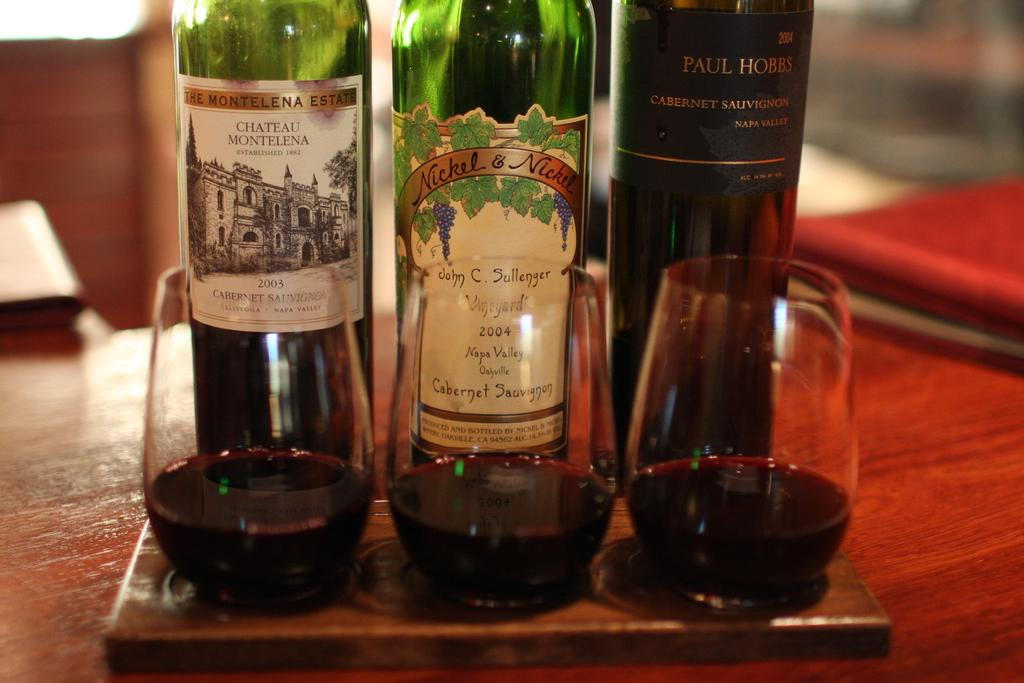<image>
Share a concise interpretation of the image provided. A bottle of wine from the John C. Sullenger vineyard is from 2004. 